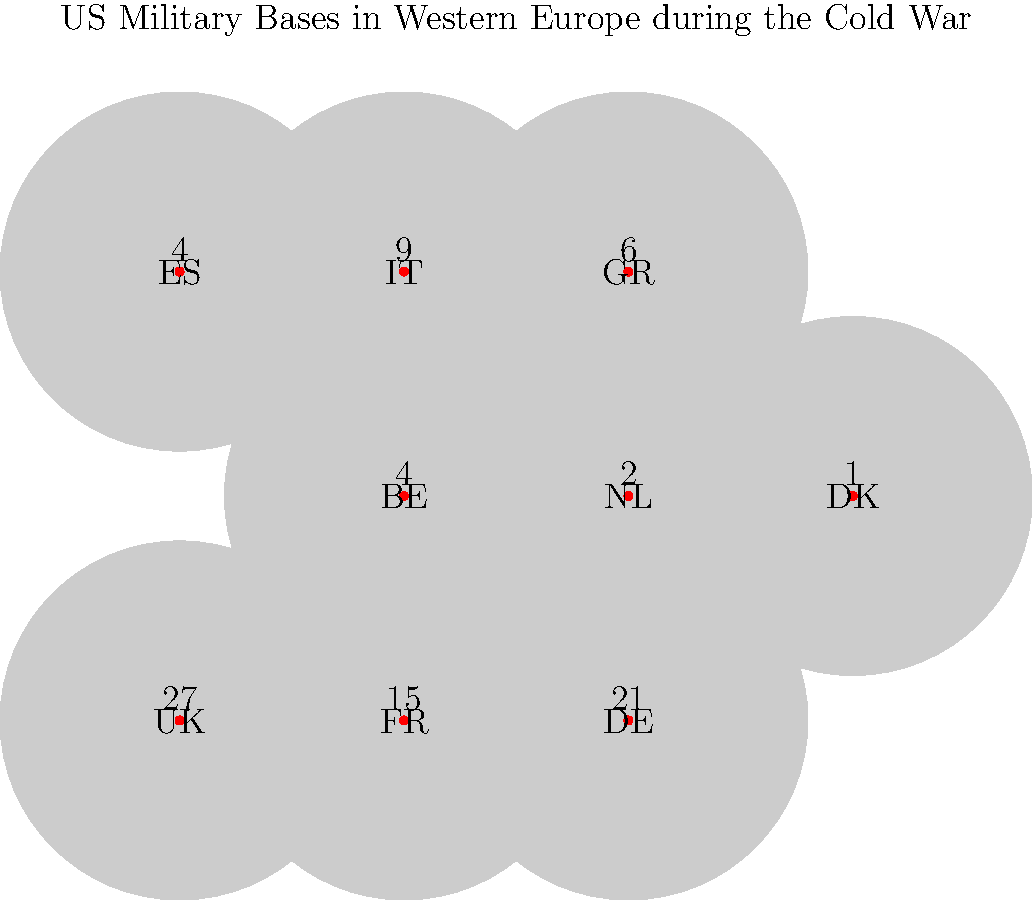Based on the map showing the distribution of US military bases in Western Europe during the Cold War, which country hosted the highest number of bases, and how many did it have? To answer this question, we need to analyze the data presented in the map:

1. The map shows nine Western European countries: UK, FR (France), DE (West Germany), BE (Belgium), NL (Netherlands), DK (Denmark), ES (Spain), IT (Italy), and GR (Greece).

2. Each country is represented by a circle with its abbreviation and a number indicating the count of US military bases.

3. We need to compare the numbers for each country:
   - UK: 27
   - FR: 15
   - DE: 21
   - BE: 4
   - NL: 2
   - DK: 1
   - ES: 4
   - IT: 9
   - GR: 6

4. The highest number among these is 27, corresponding to the UK.

Therefore, the United Kingdom (UK) hosted the highest number of US military bases during the Cold War, with a total of 27 bases.
Answer: United Kingdom (UK), 27 bases 